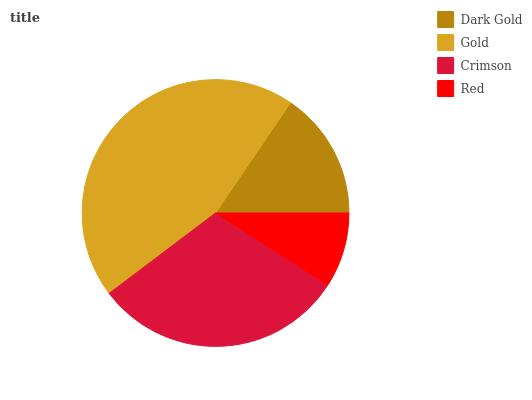Is Red the minimum?
Answer yes or no. Yes. Is Gold the maximum?
Answer yes or no. Yes. Is Crimson the minimum?
Answer yes or no. No. Is Crimson the maximum?
Answer yes or no. No. Is Gold greater than Crimson?
Answer yes or no. Yes. Is Crimson less than Gold?
Answer yes or no. Yes. Is Crimson greater than Gold?
Answer yes or no. No. Is Gold less than Crimson?
Answer yes or no. No. Is Crimson the high median?
Answer yes or no. Yes. Is Dark Gold the low median?
Answer yes or no. Yes. Is Red the high median?
Answer yes or no. No. Is Gold the low median?
Answer yes or no. No. 